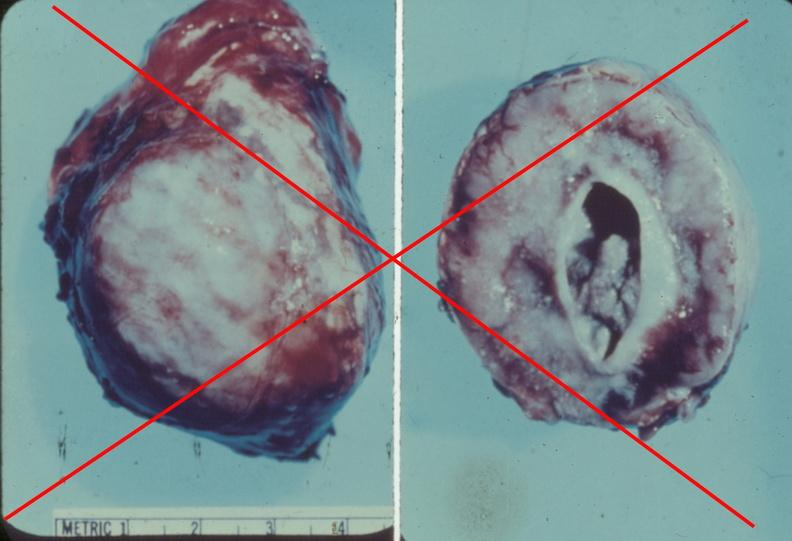s endocrine present?
Answer the question using a single word or phrase. Yes 